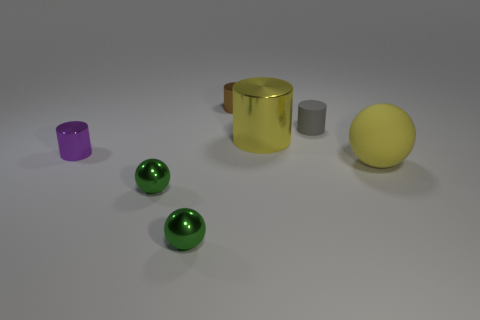Add 3 purple metal objects. How many objects exist? 10 Subtract all cylinders. How many objects are left? 3 Add 1 tiny cylinders. How many tiny cylinders are left? 4 Add 2 yellow rubber things. How many yellow rubber things exist? 3 Subtract 1 purple cylinders. How many objects are left? 6 Subtract all big yellow balls. Subtract all yellow matte balls. How many objects are left? 5 